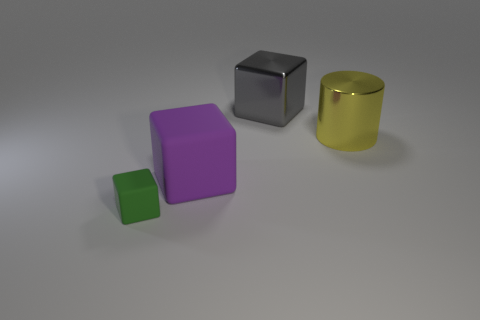There is a matte object that is right of the cube that is in front of the large block that is in front of the gray object; what color is it?
Ensure brevity in your answer.  Purple. Is the number of tiny cubes right of the purple block the same as the number of small blue rubber objects?
Your answer should be very brief. Yes. Does the rubber object that is behind the green rubber thing have the same size as the gray object?
Provide a succinct answer. Yes. What number of big things are there?
Your answer should be very brief. 3. How many blocks are on the left side of the gray thing and behind the tiny green rubber object?
Your response must be concise. 1. Is there a big purple object made of the same material as the purple block?
Provide a succinct answer. No. There is a thing to the left of the rubber thing that is behind the green matte object; what is it made of?
Your response must be concise. Rubber. Are there the same number of large yellow shiny cylinders that are right of the small rubber block and objects on the left side of the purple matte object?
Offer a very short reply. Yes. Is the yellow thing the same shape as the green object?
Your answer should be very brief. No. What is the large thing that is in front of the large gray block and on the left side of the big yellow metallic cylinder made of?
Provide a short and direct response. Rubber. 